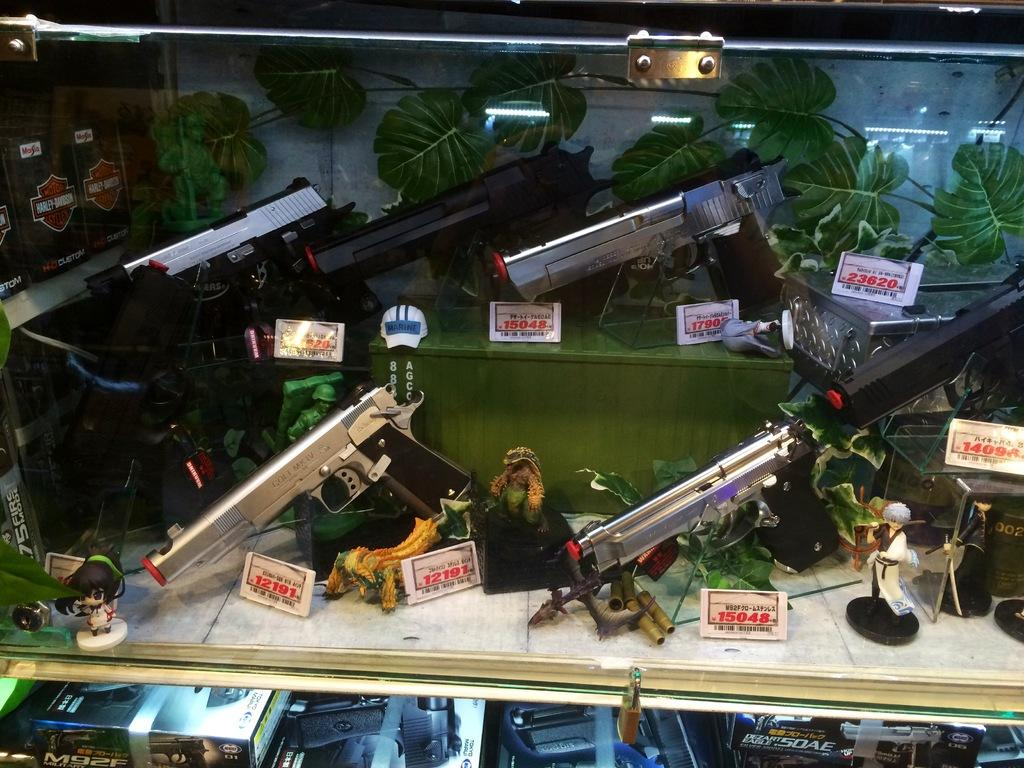What objects are placed on the table in the image? There are guns placed on the table in the image. What type of items have numbers on them in the image? There are boards with numbers in the image. What type of objects are meant for play in the image? There are toys in the image. What can be seen at the bottom of the image? There are boxes visible at the bottom of the image. What is the smell of the toys in the image? The image does not provide any information about the smell of the toys, as it is a visual medium. 